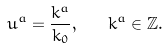Convert formula to latex. <formula><loc_0><loc_0><loc_500><loc_500>u ^ { a } = \frac { k ^ { a } } { k _ { 0 } } , \quad k ^ { a } \in \mathbb { Z } .</formula> 